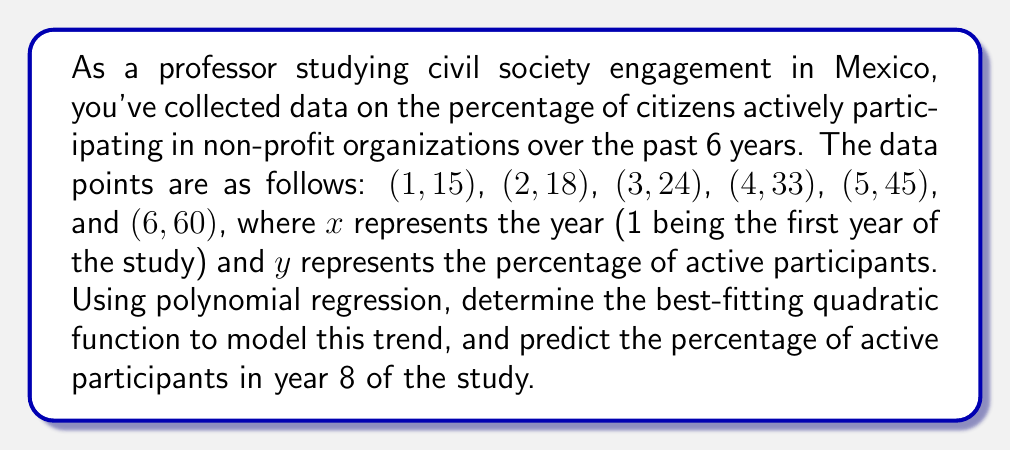What is the answer to this math problem? To solve this problem, we'll use quadratic polynomial regression to find the best-fitting function in the form $y = ax^2 + bx + c$.

Step 1: Set up the system of normal equations:
$$\begin{cases}
a\sum x^4 + b\sum x^3 + c\sum x^2 = \sum x^2y \\
a\sum x^3 + b\sum x^2 + c\sum x = \sum xy \\
a\sum x^2 + b\sum x + cn = \sum y
\end{cases}$$

Step 2: Calculate the sums:
$n = 6$
$\sum x = 21$
$\sum y = 195$
$\sum x^2 = 91$
$\sum x^3 = 441$
$\sum x^4 = 2275$
$\sum xy = 823$
$\sum x^2y = 3955$

Step 3: Substitute the values into the system of equations:
$$\begin{cases}
2275a + 441b + 91c = 3955 \\
441a + 91b + 21c = 823 \\
91a + 21b + 6c = 195
\end{cases}$$

Step 4: Solve the system of equations (using a calculator or computer algebra system):
$a = 2$
$b = -1$
$c = 14$

Step 5: Write the quadratic function:
$y = 2x^2 - x + 14$

Step 6: Predict the percentage for year 8 by substituting $x = 8$ into the function:
$y = 2(8)^2 - 8 + 14 = 128 - 8 + 14 = 134$

Therefore, the predicted percentage of active participants in year 8 is 134%.
Answer: 134% 